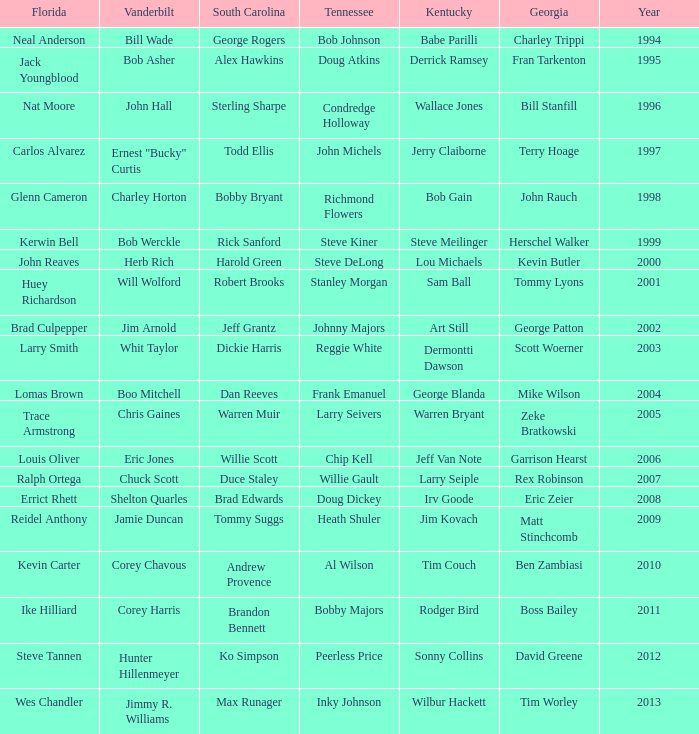What is the total Year of jeff van note ( Kentucky) 2006.0. 